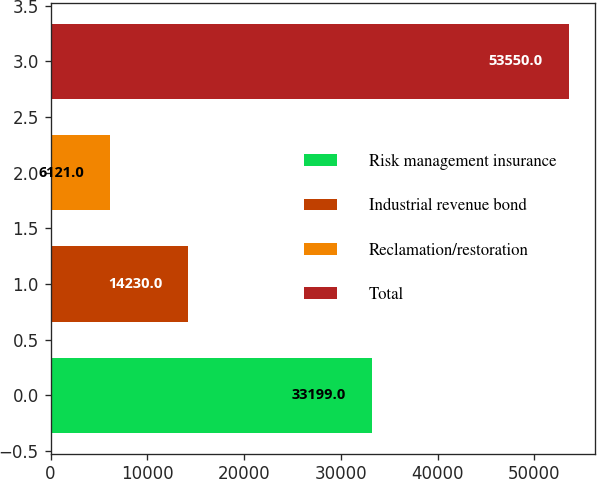Convert chart. <chart><loc_0><loc_0><loc_500><loc_500><bar_chart><fcel>Risk management insurance<fcel>Industrial revenue bond<fcel>Reclamation/restoration<fcel>Total<nl><fcel>33199<fcel>14230<fcel>6121<fcel>53550<nl></chart> 